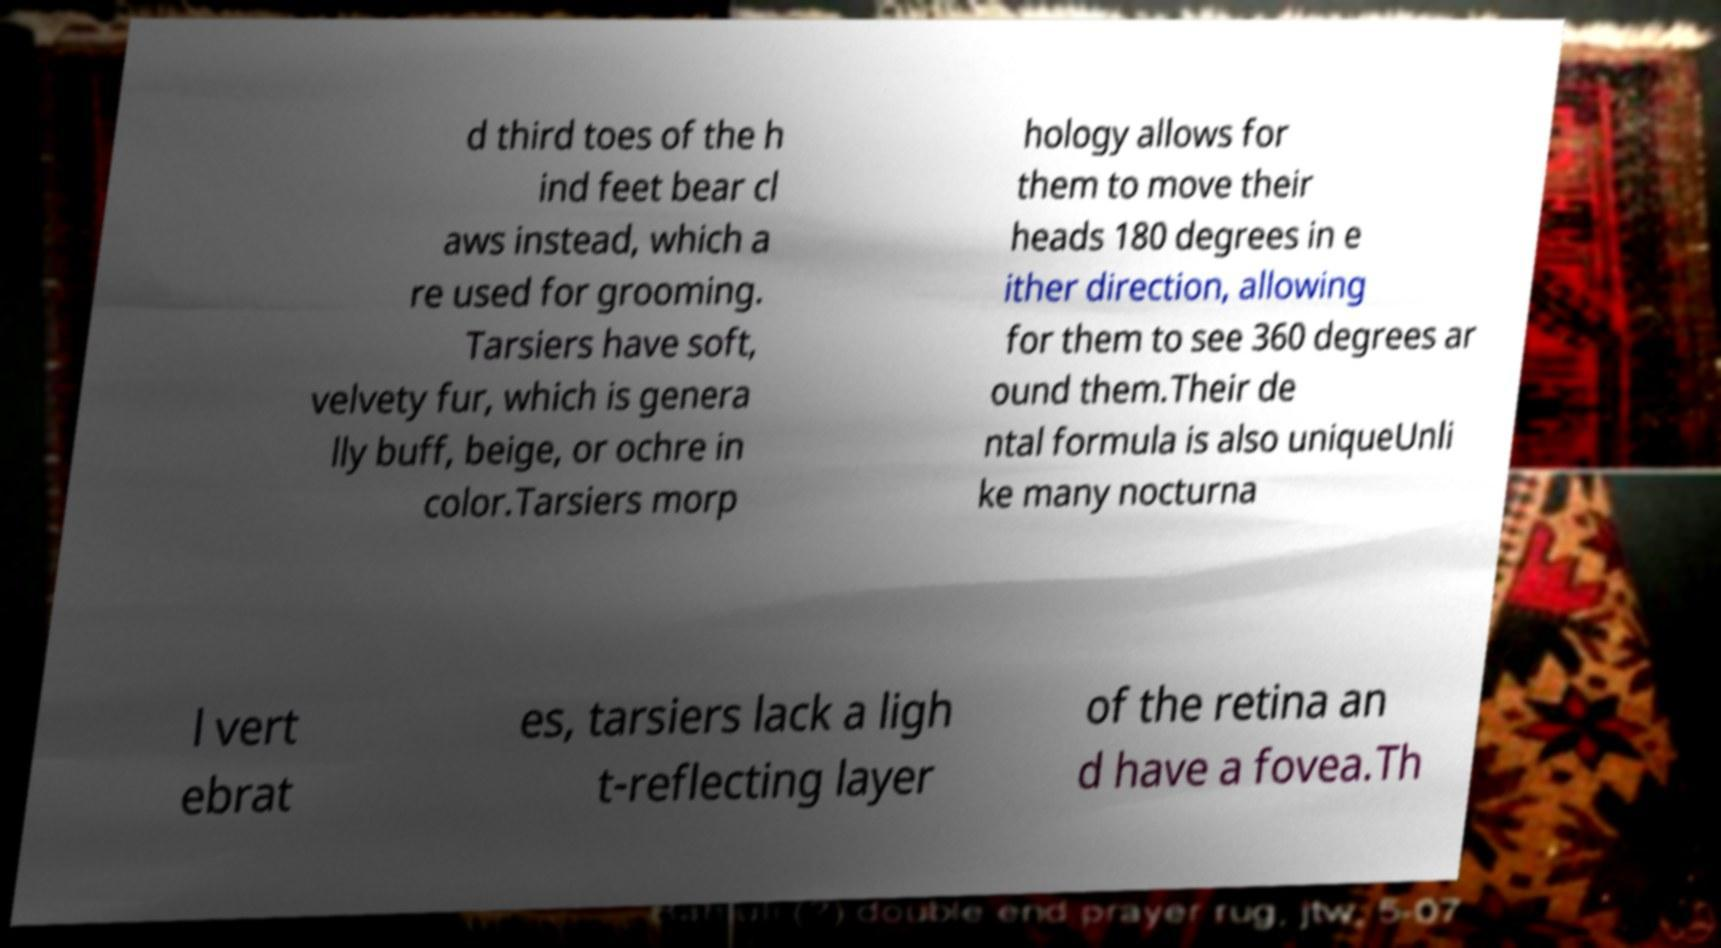Can you read and provide the text displayed in the image?This photo seems to have some interesting text. Can you extract and type it out for me? d third toes of the h ind feet bear cl aws instead, which a re used for grooming. Tarsiers have soft, velvety fur, which is genera lly buff, beige, or ochre in color.Tarsiers morp hology allows for them to move their heads 180 degrees in e ither direction, allowing for them to see 360 degrees ar ound them.Their de ntal formula is also uniqueUnli ke many nocturna l vert ebrat es, tarsiers lack a ligh t-reflecting layer of the retina an d have a fovea.Th 